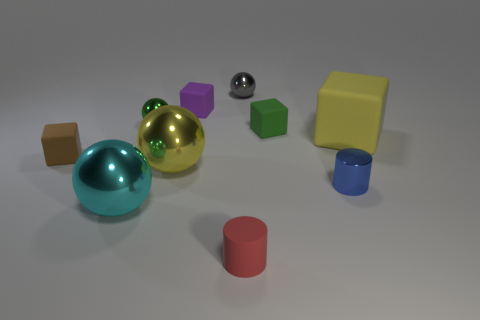Subtract all big cyan metal spheres. How many spheres are left? 3 Subtract all yellow spheres. How many spheres are left? 3 Subtract 2 balls. How many balls are left? 2 Subtract all balls. How many objects are left? 6 Add 1 red things. How many red things exist? 2 Subtract 1 purple cubes. How many objects are left? 9 Subtract all purple balls. Subtract all red cubes. How many balls are left? 4 Subtract all green cubes. Subtract all tiny blue cylinders. How many objects are left? 8 Add 8 tiny metal spheres. How many tiny metal spheres are left? 10 